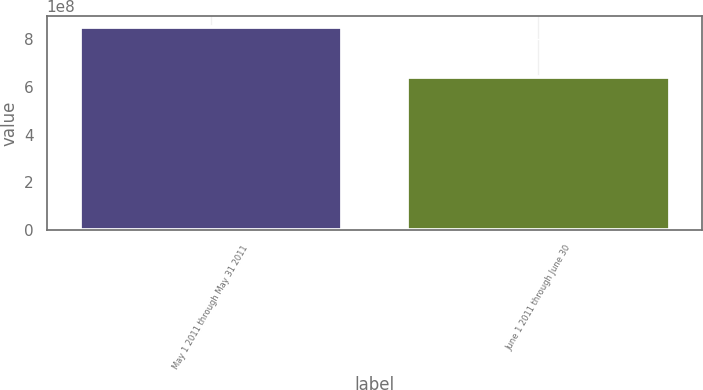Convert chart to OTSL. <chart><loc_0><loc_0><loc_500><loc_500><bar_chart><fcel>May 1 2011 through May 31 2011<fcel>June 1 2011 through June 30<nl><fcel>8.51342e+08<fcel>6.40053e+08<nl></chart> 